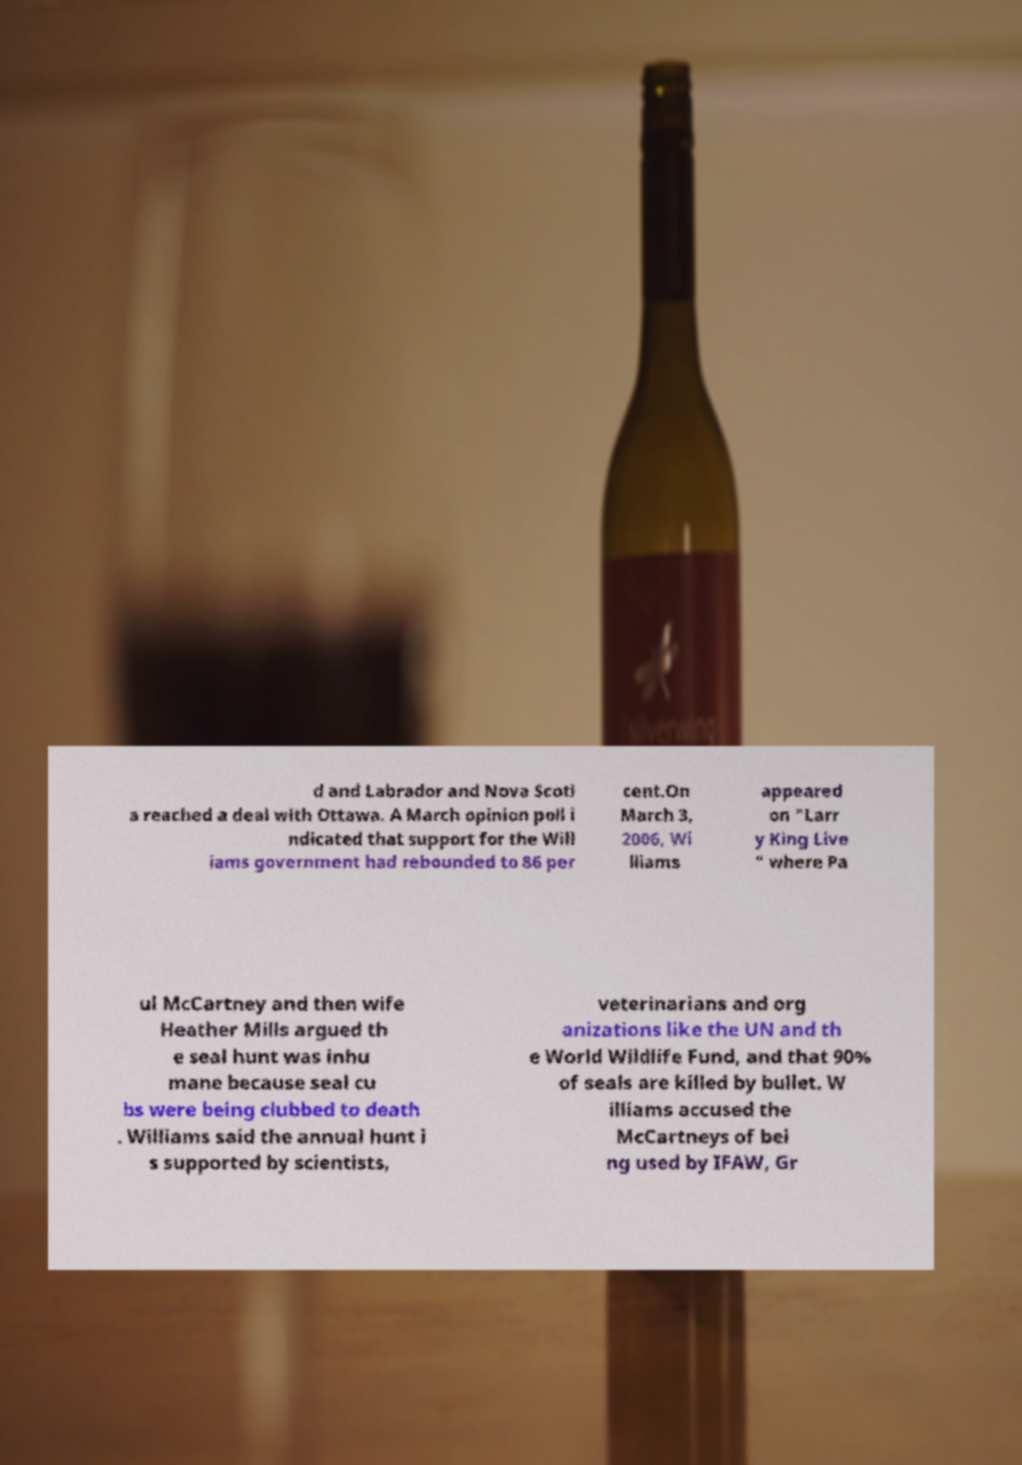Please read and relay the text visible in this image. What does it say? d and Labrador and Nova Scoti a reached a deal with Ottawa. A March opinion poll i ndicated that support for the Will iams government had rebounded to 86 per cent.On March 3, 2006, Wi lliams appeared on "Larr y King Live " where Pa ul McCartney and then wife Heather Mills argued th e seal hunt was inhu mane because seal cu bs were being clubbed to death . Williams said the annual hunt i s supported by scientists, veterinarians and org anizations like the UN and th e World Wildlife Fund, and that 90% of seals are killed by bullet. W illiams accused the McCartneys of bei ng used by IFAW, Gr 